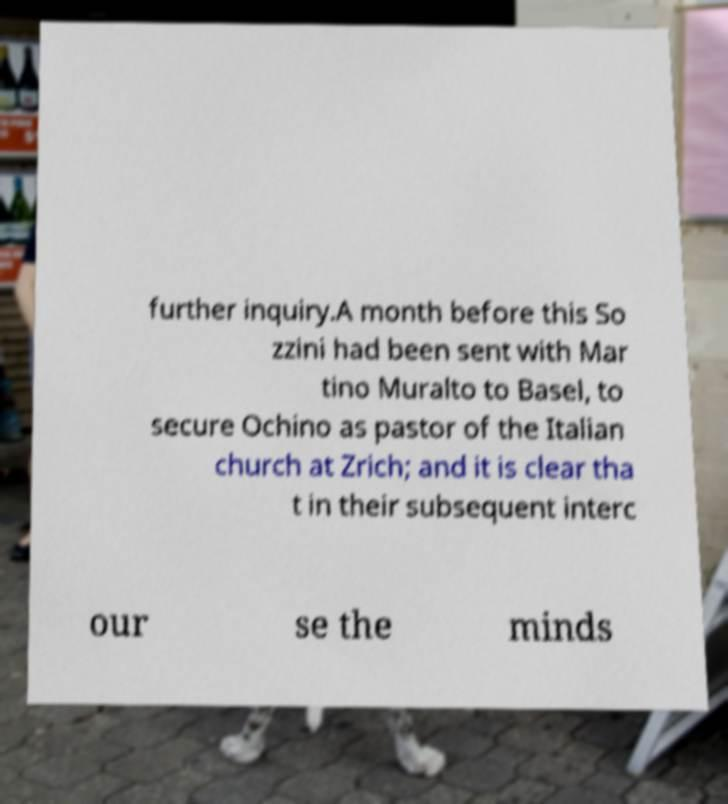There's text embedded in this image that I need extracted. Can you transcribe it verbatim? further inquiry.A month before this So zzini had been sent with Mar tino Muralto to Basel, to secure Ochino as pastor of the Italian church at Zrich; and it is clear tha t in their subsequent interc our se the minds 